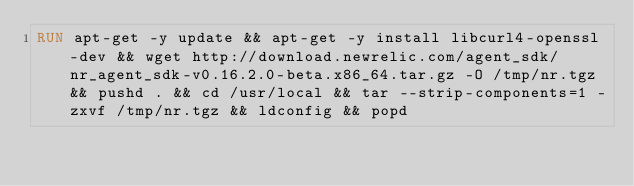Convert code to text. <code><loc_0><loc_0><loc_500><loc_500><_Dockerfile_>RUN apt-get -y update && apt-get -y install libcurl4-openssl-dev && wget http://download.newrelic.com/agent_sdk/nr_agent_sdk-v0.16.2.0-beta.x86_64.tar.gz -O /tmp/nr.tgz && pushd . && cd /usr/local && tar --strip-components=1 -zxvf /tmp/nr.tgz && ldconfig && popd
</code> 